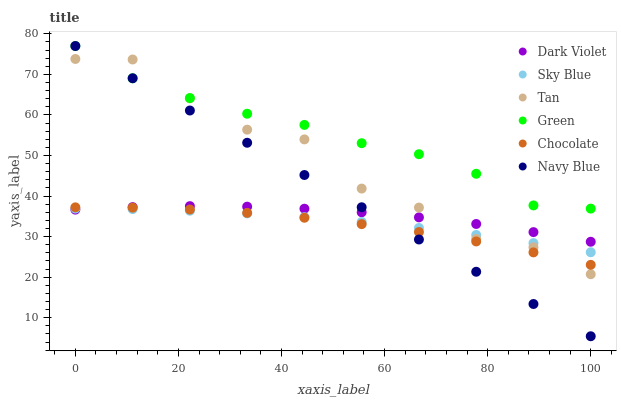Does Chocolate have the minimum area under the curve?
Answer yes or no. Yes. Does Green have the maximum area under the curve?
Answer yes or no. Yes. Does Dark Violet have the minimum area under the curve?
Answer yes or no. No. Does Dark Violet have the maximum area under the curve?
Answer yes or no. No. Is Navy Blue the smoothest?
Answer yes or no. Yes. Is Tan the roughest?
Answer yes or no. Yes. Is Dark Violet the smoothest?
Answer yes or no. No. Is Dark Violet the roughest?
Answer yes or no. No. Does Navy Blue have the lowest value?
Answer yes or no. Yes. Does Dark Violet have the lowest value?
Answer yes or no. No. Does Green have the highest value?
Answer yes or no. Yes. Does Dark Violet have the highest value?
Answer yes or no. No. Is Dark Violet less than Green?
Answer yes or no. Yes. Is Green greater than Chocolate?
Answer yes or no. Yes. Does Dark Violet intersect Tan?
Answer yes or no. Yes. Is Dark Violet less than Tan?
Answer yes or no. No. Is Dark Violet greater than Tan?
Answer yes or no. No. Does Dark Violet intersect Green?
Answer yes or no. No. 